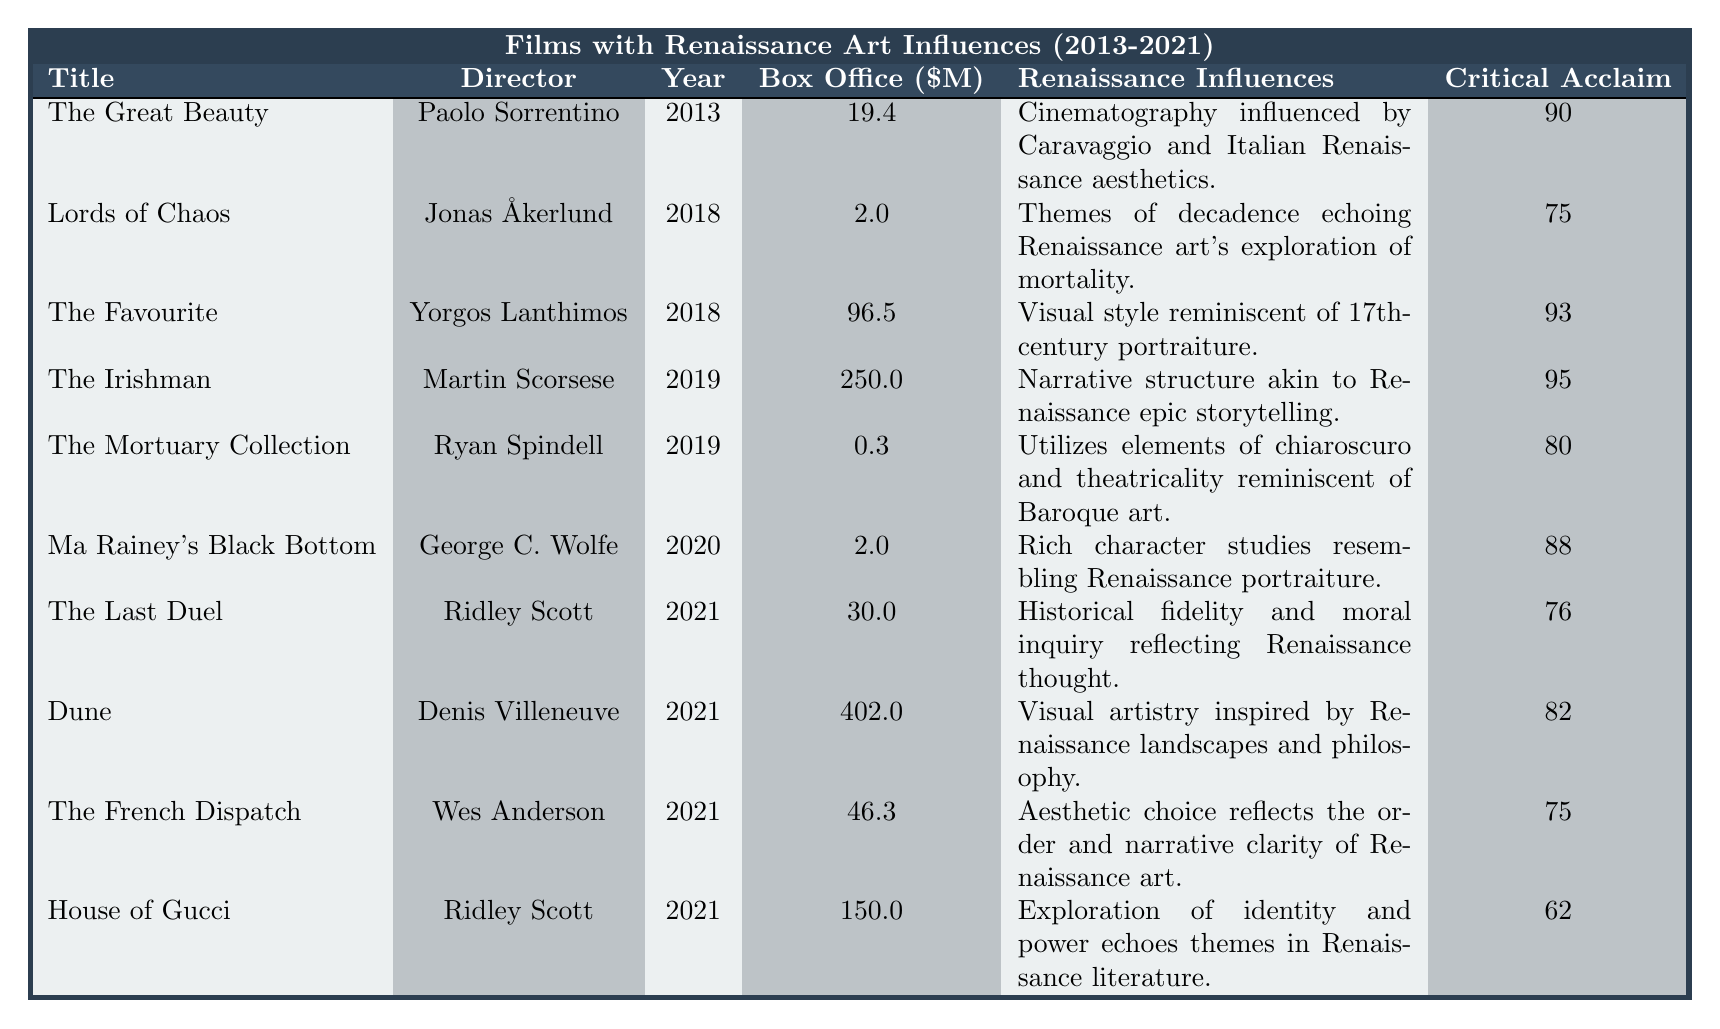What is the box office revenue of "The Irishman"? The box office revenue for "The Irishman" is listed in the table; it shows a value of $250 million.
Answer: 250 million Which film released in 2021 had the highest box office earnings? In the table, we look at the box office values for films released in 2021. "Dune" has the highest value at $402 million.
Answer: Dune What renaissance influences are cited for "The Favourite"? The table lists "The Favourite" as having visual style reminiscent of 17th-century portraiture as its renaissance influence.
Answer: Visual style reminiscent of 17th-century portraiture How many films in the table have a critical acclaim rating of 90 or above? By counting the films in the critical acclaim column, "The Great Beauty," "The Favourite," "The Irishman," and "Ma Rainey's Black Bottom" all have ratings of 90 or above. This totals four films.
Answer: 4 What is the average box office revenue of films directed by Ridley Scott? The box office revenue for Ridley Scott's films "The Last Duel" ($30 million) and "House of Gucci" ($150 million) is added together: $30M + $150M = $180M. Dividing by 2 gives an average of $90 million.
Answer: 90 million Is "Lords of Chaos" critically acclaimed? Checking the critical acclaim score in the table, "Lords of Chaos" has a score of 75, which is relatively lower compared to others, but still within a reasonable range for acclaim.
Answer: Yes What is the total box office revenue of all films with Renaissance influences in 2021? Adding the box office revenues of the films from 2021: "Dune" ($402 million), "The Last Duel" ($30 million), "The French Dispatch" ($46.3 million), and "House of Gucci" ($150 million) gives $402M + $30M + $46.3M + $150M = $628.3 million.
Answer: 628.3 million Which film shows influences from Caravaggio? The film "The Great Beauty" is noted for having cinematography influenced by Caravaggio and Italian Renaissance aesthetics.
Answer: The Great Beauty What was the critical acclaim average for films with a box office revenue below $10 million? The only film with a box office below $10 million is "The Mortuary Collection" ($0.3 million) and "Lords of Chaos," (2 million). Their critical acclaim scores are 80 and 75 respectively. The average is (80 + 75) / 2 = 77.5.
Answer: 77.5 Which director has the highest box office average for their films listed in the table? Let's calculate the averages: Paolo Sorrentino ($19.4M), Yorgos Lanthimos ($96.5M), Martin Scorsese ($250M), George C. Wolfe ($2M), Ridley Scott ($60M average from two films), and Denis Villeneuve ($402M). The highest is from Denis Villeneuve who directed "Dune."
Answer: Denis Villeneuve 